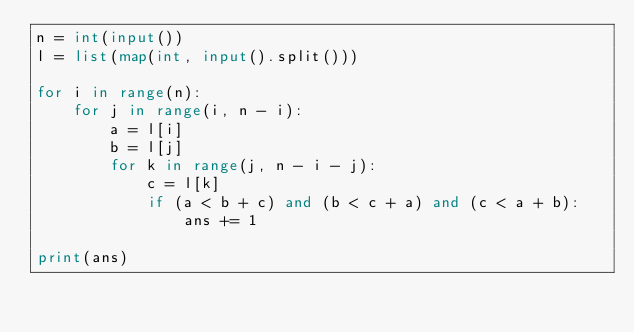<code> <loc_0><loc_0><loc_500><loc_500><_Python_>n = int(input())
l = list(map(int, input().split()))

for i in range(n):
    for j in range(i, n - i):
        a = l[i]
        b = l[j]
        for k in range(j, n - i - j):
            c = l[k]
            if (a < b + c) and (b < c + a) and (c < a + b):
                ans += 1

print(ans)
</code> 